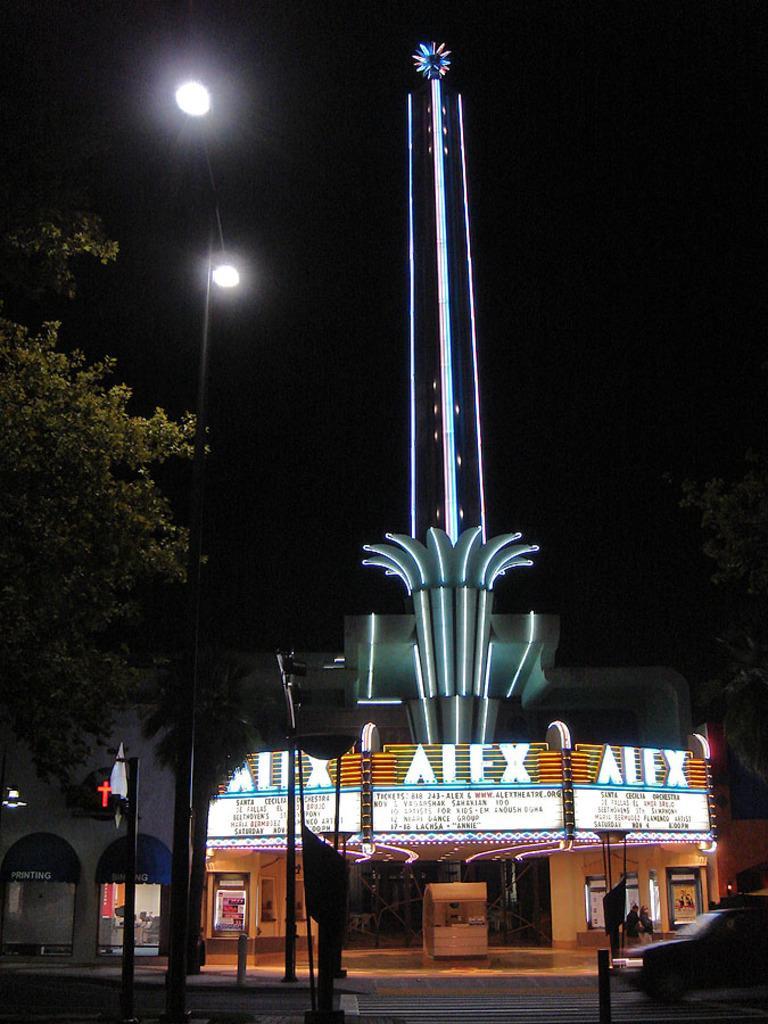Describe this image in one or two sentences. In this image there is a tower of a building, in front of that there is a vehicle moving on the road, street lights, poles and the background is dark. 